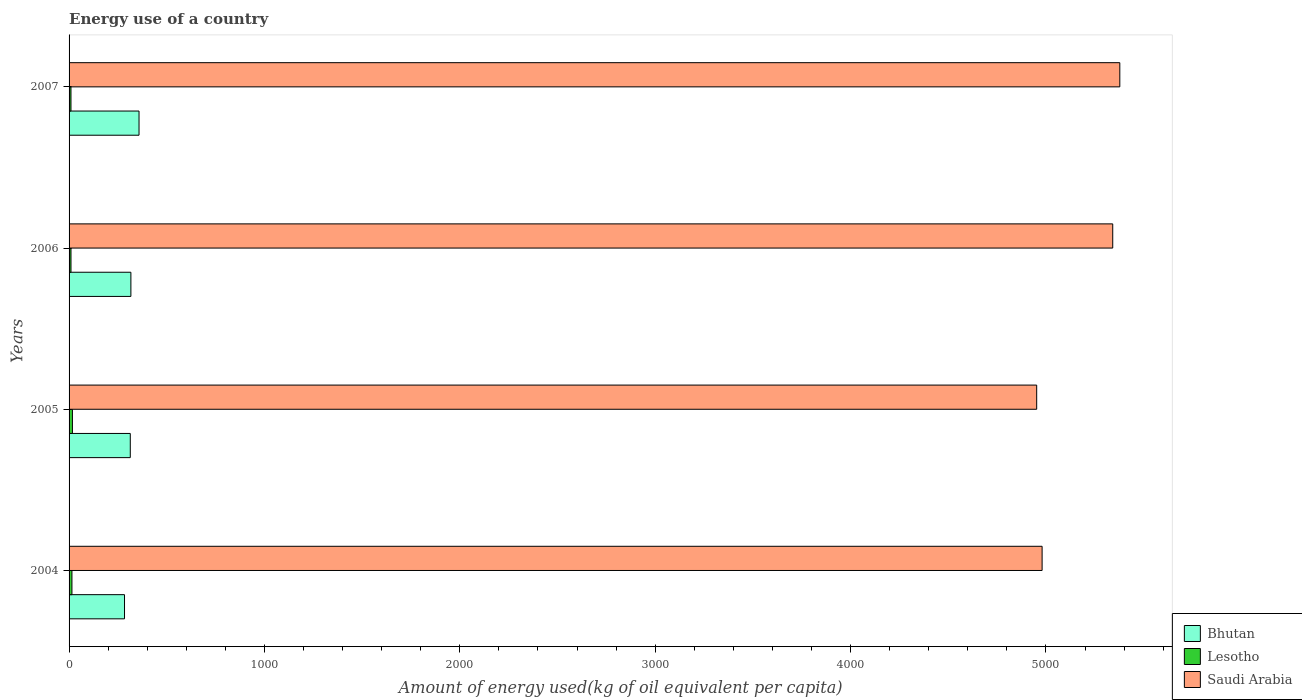How many groups of bars are there?
Provide a short and direct response. 4. How many bars are there on the 3rd tick from the top?
Offer a terse response. 3. What is the label of the 1st group of bars from the top?
Offer a terse response. 2007. What is the amount of energy used in in Saudi Arabia in 2005?
Keep it short and to the point. 4952.56. Across all years, what is the maximum amount of energy used in in Lesotho?
Offer a very short reply. 17.14. Across all years, what is the minimum amount of energy used in in Lesotho?
Provide a succinct answer. 9.72. In which year was the amount of energy used in in Lesotho maximum?
Give a very brief answer. 2005. What is the total amount of energy used in in Saudi Arabia in the graph?
Provide a succinct answer. 2.07e+04. What is the difference between the amount of energy used in in Bhutan in 2004 and that in 2007?
Provide a short and direct response. -74.24. What is the difference between the amount of energy used in in Saudi Arabia in 2005 and the amount of energy used in in Lesotho in 2007?
Give a very brief answer. 4942.85. What is the average amount of energy used in in Bhutan per year?
Your answer should be compact. 317.88. In the year 2005, what is the difference between the amount of energy used in in Bhutan and amount of energy used in in Lesotho?
Keep it short and to the point. 296.15. In how many years, is the amount of energy used in in Lesotho greater than 2000 kg?
Provide a short and direct response. 0. What is the ratio of the amount of energy used in in Saudi Arabia in 2004 to that in 2007?
Offer a terse response. 0.93. Is the amount of energy used in in Saudi Arabia in 2005 less than that in 2006?
Provide a succinct answer. Yes. What is the difference between the highest and the second highest amount of energy used in in Lesotho?
Offer a very short reply. 2.49. What is the difference between the highest and the lowest amount of energy used in in Lesotho?
Offer a terse response. 7.42. What does the 1st bar from the top in 2004 represents?
Your response must be concise. Saudi Arabia. What does the 3rd bar from the bottom in 2006 represents?
Provide a short and direct response. Saudi Arabia. Is it the case that in every year, the sum of the amount of energy used in in Lesotho and amount of energy used in in Bhutan is greater than the amount of energy used in in Saudi Arabia?
Offer a very short reply. No. How many bars are there?
Your answer should be compact. 12. How many years are there in the graph?
Give a very brief answer. 4. How many legend labels are there?
Your answer should be compact. 3. What is the title of the graph?
Provide a succinct answer. Energy use of a country. What is the label or title of the X-axis?
Keep it short and to the point. Amount of energy used(kg of oil equivalent per capita). What is the Amount of energy used(kg of oil equivalent per capita) of Bhutan in 2004?
Make the answer very short. 283.81. What is the Amount of energy used(kg of oil equivalent per capita) in Lesotho in 2004?
Your response must be concise. 14.64. What is the Amount of energy used(kg of oil equivalent per capita) of Saudi Arabia in 2004?
Your answer should be compact. 4980.31. What is the Amount of energy used(kg of oil equivalent per capita) of Bhutan in 2005?
Provide a succinct answer. 313.29. What is the Amount of energy used(kg of oil equivalent per capita) of Lesotho in 2005?
Keep it short and to the point. 17.14. What is the Amount of energy used(kg of oil equivalent per capita) in Saudi Arabia in 2005?
Offer a terse response. 4952.56. What is the Amount of energy used(kg of oil equivalent per capita) in Bhutan in 2006?
Your answer should be compact. 316.38. What is the Amount of energy used(kg of oil equivalent per capita) in Lesotho in 2006?
Offer a terse response. 9.79. What is the Amount of energy used(kg of oil equivalent per capita) of Saudi Arabia in 2006?
Give a very brief answer. 5341.83. What is the Amount of energy used(kg of oil equivalent per capita) of Bhutan in 2007?
Ensure brevity in your answer.  358.05. What is the Amount of energy used(kg of oil equivalent per capita) in Lesotho in 2007?
Provide a succinct answer. 9.72. What is the Amount of energy used(kg of oil equivalent per capita) of Saudi Arabia in 2007?
Provide a succinct answer. 5378.06. Across all years, what is the maximum Amount of energy used(kg of oil equivalent per capita) in Bhutan?
Your answer should be compact. 358.05. Across all years, what is the maximum Amount of energy used(kg of oil equivalent per capita) in Lesotho?
Give a very brief answer. 17.14. Across all years, what is the maximum Amount of energy used(kg of oil equivalent per capita) of Saudi Arabia?
Offer a terse response. 5378.06. Across all years, what is the minimum Amount of energy used(kg of oil equivalent per capita) in Bhutan?
Provide a succinct answer. 283.81. Across all years, what is the minimum Amount of energy used(kg of oil equivalent per capita) of Lesotho?
Keep it short and to the point. 9.72. Across all years, what is the minimum Amount of energy used(kg of oil equivalent per capita) of Saudi Arabia?
Provide a short and direct response. 4952.56. What is the total Amount of energy used(kg of oil equivalent per capita) in Bhutan in the graph?
Your answer should be very brief. 1271.52. What is the total Amount of energy used(kg of oil equivalent per capita) of Lesotho in the graph?
Provide a short and direct response. 51.29. What is the total Amount of energy used(kg of oil equivalent per capita) of Saudi Arabia in the graph?
Your answer should be compact. 2.07e+04. What is the difference between the Amount of energy used(kg of oil equivalent per capita) in Bhutan in 2004 and that in 2005?
Give a very brief answer. -29.48. What is the difference between the Amount of energy used(kg of oil equivalent per capita) of Lesotho in 2004 and that in 2005?
Your response must be concise. -2.49. What is the difference between the Amount of energy used(kg of oil equivalent per capita) of Saudi Arabia in 2004 and that in 2005?
Ensure brevity in your answer.  27.75. What is the difference between the Amount of energy used(kg of oil equivalent per capita) in Bhutan in 2004 and that in 2006?
Keep it short and to the point. -32.57. What is the difference between the Amount of energy used(kg of oil equivalent per capita) in Lesotho in 2004 and that in 2006?
Your response must be concise. 4.85. What is the difference between the Amount of energy used(kg of oil equivalent per capita) in Saudi Arabia in 2004 and that in 2006?
Keep it short and to the point. -361.52. What is the difference between the Amount of energy used(kg of oil equivalent per capita) in Bhutan in 2004 and that in 2007?
Make the answer very short. -74.24. What is the difference between the Amount of energy used(kg of oil equivalent per capita) in Lesotho in 2004 and that in 2007?
Your response must be concise. 4.93. What is the difference between the Amount of energy used(kg of oil equivalent per capita) of Saudi Arabia in 2004 and that in 2007?
Offer a terse response. -397.74. What is the difference between the Amount of energy used(kg of oil equivalent per capita) in Bhutan in 2005 and that in 2006?
Your response must be concise. -3.09. What is the difference between the Amount of energy used(kg of oil equivalent per capita) in Lesotho in 2005 and that in 2006?
Your answer should be very brief. 7.34. What is the difference between the Amount of energy used(kg of oil equivalent per capita) of Saudi Arabia in 2005 and that in 2006?
Your answer should be compact. -389.27. What is the difference between the Amount of energy used(kg of oil equivalent per capita) in Bhutan in 2005 and that in 2007?
Your answer should be very brief. -44.76. What is the difference between the Amount of energy used(kg of oil equivalent per capita) of Lesotho in 2005 and that in 2007?
Make the answer very short. 7.42. What is the difference between the Amount of energy used(kg of oil equivalent per capita) of Saudi Arabia in 2005 and that in 2007?
Keep it short and to the point. -425.5. What is the difference between the Amount of energy used(kg of oil equivalent per capita) of Bhutan in 2006 and that in 2007?
Keep it short and to the point. -41.67. What is the difference between the Amount of energy used(kg of oil equivalent per capita) in Lesotho in 2006 and that in 2007?
Offer a very short reply. 0.08. What is the difference between the Amount of energy used(kg of oil equivalent per capita) in Saudi Arabia in 2006 and that in 2007?
Give a very brief answer. -36.23. What is the difference between the Amount of energy used(kg of oil equivalent per capita) of Bhutan in 2004 and the Amount of energy used(kg of oil equivalent per capita) of Lesotho in 2005?
Ensure brevity in your answer.  266.67. What is the difference between the Amount of energy used(kg of oil equivalent per capita) in Bhutan in 2004 and the Amount of energy used(kg of oil equivalent per capita) in Saudi Arabia in 2005?
Provide a succinct answer. -4668.75. What is the difference between the Amount of energy used(kg of oil equivalent per capita) of Lesotho in 2004 and the Amount of energy used(kg of oil equivalent per capita) of Saudi Arabia in 2005?
Offer a terse response. -4937.92. What is the difference between the Amount of energy used(kg of oil equivalent per capita) of Bhutan in 2004 and the Amount of energy used(kg of oil equivalent per capita) of Lesotho in 2006?
Offer a terse response. 274.01. What is the difference between the Amount of energy used(kg of oil equivalent per capita) of Bhutan in 2004 and the Amount of energy used(kg of oil equivalent per capita) of Saudi Arabia in 2006?
Provide a short and direct response. -5058.02. What is the difference between the Amount of energy used(kg of oil equivalent per capita) of Lesotho in 2004 and the Amount of energy used(kg of oil equivalent per capita) of Saudi Arabia in 2006?
Offer a terse response. -5327.19. What is the difference between the Amount of energy used(kg of oil equivalent per capita) of Bhutan in 2004 and the Amount of energy used(kg of oil equivalent per capita) of Lesotho in 2007?
Provide a succinct answer. 274.09. What is the difference between the Amount of energy used(kg of oil equivalent per capita) in Bhutan in 2004 and the Amount of energy used(kg of oil equivalent per capita) in Saudi Arabia in 2007?
Keep it short and to the point. -5094.25. What is the difference between the Amount of energy used(kg of oil equivalent per capita) of Lesotho in 2004 and the Amount of energy used(kg of oil equivalent per capita) of Saudi Arabia in 2007?
Your response must be concise. -5363.41. What is the difference between the Amount of energy used(kg of oil equivalent per capita) of Bhutan in 2005 and the Amount of energy used(kg of oil equivalent per capita) of Lesotho in 2006?
Your response must be concise. 303.49. What is the difference between the Amount of energy used(kg of oil equivalent per capita) of Bhutan in 2005 and the Amount of energy used(kg of oil equivalent per capita) of Saudi Arabia in 2006?
Your response must be concise. -5028.55. What is the difference between the Amount of energy used(kg of oil equivalent per capita) of Lesotho in 2005 and the Amount of energy used(kg of oil equivalent per capita) of Saudi Arabia in 2006?
Provide a short and direct response. -5324.7. What is the difference between the Amount of energy used(kg of oil equivalent per capita) of Bhutan in 2005 and the Amount of energy used(kg of oil equivalent per capita) of Lesotho in 2007?
Make the answer very short. 303.57. What is the difference between the Amount of energy used(kg of oil equivalent per capita) in Bhutan in 2005 and the Amount of energy used(kg of oil equivalent per capita) in Saudi Arabia in 2007?
Your response must be concise. -5064.77. What is the difference between the Amount of energy used(kg of oil equivalent per capita) of Lesotho in 2005 and the Amount of energy used(kg of oil equivalent per capita) of Saudi Arabia in 2007?
Keep it short and to the point. -5360.92. What is the difference between the Amount of energy used(kg of oil equivalent per capita) of Bhutan in 2006 and the Amount of energy used(kg of oil equivalent per capita) of Lesotho in 2007?
Your response must be concise. 306.66. What is the difference between the Amount of energy used(kg of oil equivalent per capita) of Bhutan in 2006 and the Amount of energy used(kg of oil equivalent per capita) of Saudi Arabia in 2007?
Offer a very short reply. -5061.68. What is the difference between the Amount of energy used(kg of oil equivalent per capita) in Lesotho in 2006 and the Amount of energy used(kg of oil equivalent per capita) in Saudi Arabia in 2007?
Give a very brief answer. -5368.26. What is the average Amount of energy used(kg of oil equivalent per capita) of Bhutan per year?
Offer a very short reply. 317.88. What is the average Amount of energy used(kg of oil equivalent per capita) in Lesotho per year?
Offer a very short reply. 12.82. What is the average Amount of energy used(kg of oil equivalent per capita) of Saudi Arabia per year?
Your response must be concise. 5163.19. In the year 2004, what is the difference between the Amount of energy used(kg of oil equivalent per capita) in Bhutan and Amount of energy used(kg of oil equivalent per capita) in Lesotho?
Your answer should be very brief. 269.16. In the year 2004, what is the difference between the Amount of energy used(kg of oil equivalent per capita) of Bhutan and Amount of energy used(kg of oil equivalent per capita) of Saudi Arabia?
Provide a short and direct response. -4696.51. In the year 2004, what is the difference between the Amount of energy used(kg of oil equivalent per capita) of Lesotho and Amount of energy used(kg of oil equivalent per capita) of Saudi Arabia?
Make the answer very short. -4965.67. In the year 2005, what is the difference between the Amount of energy used(kg of oil equivalent per capita) of Bhutan and Amount of energy used(kg of oil equivalent per capita) of Lesotho?
Your response must be concise. 296.15. In the year 2005, what is the difference between the Amount of energy used(kg of oil equivalent per capita) of Bhutan and Amount of energy used(kg of oil equivalent per capita) of Saudi Arabia?
Keep it short and to the point. -4639.28. In the year 2005, what is the difference between the Amount of energy used(kg of oil equivalent per capita) in Lesotho and Amount of energy used(kg of oil equivalent per capita) in Saudi Arabia?
Keep it short and to the point. -4935.43. In the year 2006, what is the difference between the Amount of energy used(kg of oil equivalent per capita) of Bhutan and Amount of energy used(kg of oil equivalent per capita) of Lesotho?
Keep it short and to the point. 306.59. In the year 2006, what is the difference between the Amount of energy used(kg of oil equivalent per capita) of Bhutan and Amount of energy used(kg of oil equivalent per capita) of Saudi Arabia?
Your response must be concise. -5025.45. In the year 2006, what is the difference between the Amount of energy used(kg of oil equivalent per capita) in Lesotho and Amount of energy used(kg of oil equivalent per capita) in Saudi Arabia?
Offer a terse response. -5332.04. In the year 2007, what is the difference between the Amount of energy used(kg of oil equivalent per capita) in Bhutan and Amount of energy used(kg of oil equivalent per capita) in Lesotho?
Provide a short and direct response. 348.33. In the year 2007, what is the difference between the Amount of energy used(kg of oil equivalent per capita) in Bhutan and Amount of energy used(kg of oil equivalent per capita) in Saudi Arabia?
Give a very brief answer. -5020.01. In the year 2007, what is the difference between the Amount of energy used(kg of oil equivalent per capita) of Lesotho and Amount of energy used(kg of oil equivalent per capita) of Saudi Arabia?
Give a very brief answer. -5368.34. What is the ratio of the Amount of energy used(kg of oil equivalent per capita) in Bhutan in 2004 to that in 2005?
Provide a succinct answer. 0.91. What is the ratio of the Amount of energy used(kg of oil equivalent per capita) in Lesotho in 2004 to that in 2005?
Ensure brevity in your answer.  0.85. What is the ratio of the Amount of energy used(kg of oil equivalent per capita) of Saudi Arabia in 2004 to that in 2005?
Make the answer very short. 1.01. What is the ratio of the Amount of energy used(kg of oil equivalent per capita) of Bhutan in 2004 to that in 2006?
Give a very brief answer. 0.9. What is the ratio of the Amount of energy used(kg of oil equivalent per capita) in Lesotho in 2004 to that in 2006?
Offer a terse response. 1.5. What is the ratio of the Amount of energy used(kg of oil equivalent per capita) in Saudi Arabia in 2004 to that in 2006?
Provide a short and direct response. 0.93. What is the ratio of the Amount of energy used(kg of oil equivalent per capita) in Bhutan in 2004 to that in 2007?
Offer a terse response. 0.79. What is the ratio of the Amount of energy used(kg of oil equivalent per capita) of Lesotho in 2004 to that in 2007?
Provide a short and direct response. 1.51. What is the ratio of the Amount of energy used(kg of oil equivalent per capita) of Saudi Arabia in 2004 to that in 2007?
Provide a short and direct response. 0.93. What is the ratio of the Amount of energy used(kg of oil equivalent per capita) in Bhutan in 2005 to that in 2006?
Provide a short and direct response. 0.99. What is the ratio of the Amount of energy used(kg of oil equivalent per capita) in Lesotho in 2005 to that in 2006?
Make the answer very short. 1.75. What is the ratio of the Amount of energy used(kg of oil equivalent per capita) in Saudi Arabia in 2005 to that in 2006?
Your response must be concise. 0.93. What is the ratio of the Amount of energy used(kg of oil equivalent per capita) of Lesotho in 2005 to that in 2007?
Provide a succinct answer. 1.76. What is the ratio of the Amount of energy used(kg of oil equivalent per capita) of Saudi Arabia in 2005 to that in 2007?
Keep it short and to the point. 0.92. What is the ratio of the Amount of energy used(kg of oil equivalent per capita) of Bhutan in 2006 to that in 2007?
Keep it short and to the point. 0.88. What is the ratio of the Amount of energy used(kg of oil equivalent per capita) in Lesotho in 2006 to that in 2007?
Keep it short and to the point. 1.01. What is the difference between the highest and the second highest Amount of energy used(kg of oil equivalent per capita) in Bhutan?
Make the answer very short. 41.67. What is the difference between the highest and the second highest Amount of energy used(kg of oil equivalent per capita) in Lesotho?
Keep it short and to the point. 2.49. What is the difference between the highest and the second highest Amount of energy used(kg of oil equivalent per capita) of Saudi Arabia?
Offer a very short reply. 36.23. What is the difference between the highest and the lowest Amount of energy used(kg of oil equivalent per capita) in Bhutan?
Provide a short and direct response. 74.24. What is the difference between the highest and the lowest Amount of energy used(kg of oil equivalent per capita) of Lesotho?
Your answer should be very brief. 7.42. What is the difference between the highest and the lowest Amount of energy used(kg of oil equivalent per capita) of Saudi Arabia?
Provide a succinct answer. 425.5. 